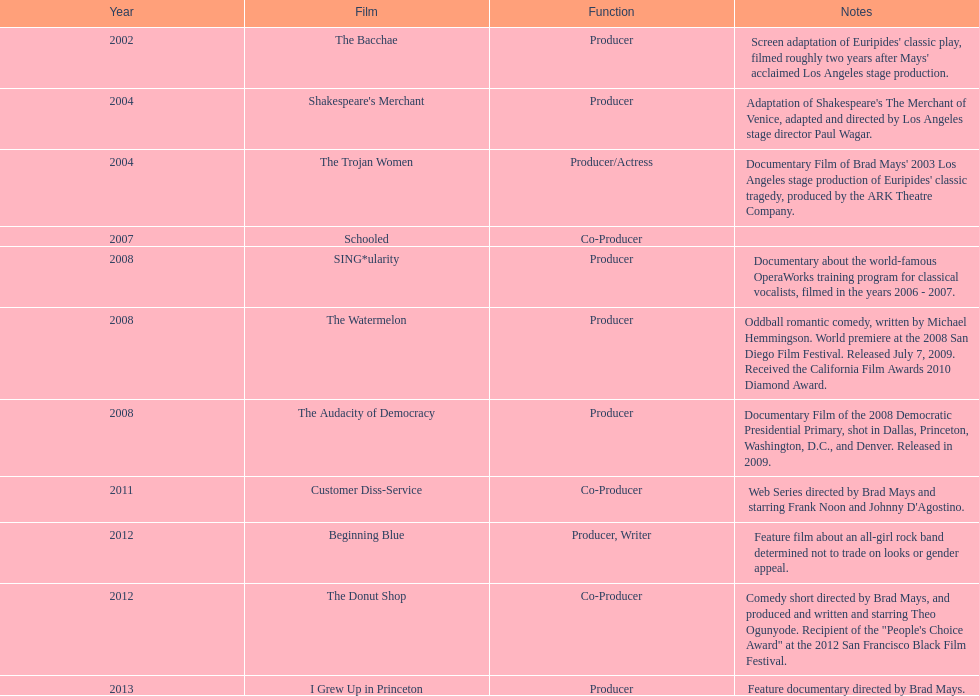Can you parse all the data within this table? {'header': ['Year', 'Film', 'Function', 'Notes'], 'rows': [['2002', 'The Bacchae', 'Producer', "Screen adaptation of Euripides' classic play, filmed roughly two years after Mays' acclaimed Los Angeles stage production."], ['2004', "Shakespeare's Merchant", 'Producer', "Adaptation of Shakespeare's The Merchant of Venice, adapted and directed by Los Angeles stage director Paul Wagar."], ['2004', 'The Trojan Women', 'Producer/Actress', "Documentary Film of Brad Mays' 2003 Los Angeles stage production of Euripides' classic tragedy, produced by the ARK Theatre Company."], ['2007', 'Schooled', 'Co-Producer', ''], ['2008', 'SING*ularity', 'Producer', 'Documentary about the world-famous OperaWorks training program for classical vocalists, filmed in the years 2006 - 2007.'], ['2008', 'The Watermelon', 'Producer', 'Oddball romantic comedy, written by Michael Hemmingson. World premiere at the 2008 San Diego Film Festival. Released July 7, 2009. Received the California Film Awards 2010 Diamond Award.'], ['2008', 'The Audacity of Democracy', 'Producer', 'Documentary Film of the 2008 Democratic Presidential Primary, shot in Dallas, Princeton, Washington, D.C., and Denver. Released in 2009.'], ['2011', 'Customer Diss-Service', 'Co-Producer', "Web Series directed by Brad Mays and starring Frank Noon and Johnny D'Agostino."], ['2012', 'Beginning Blue', 'Producer, Writer', 'Feature film about an all-girl rock band determined not to trade on looks or gender appeal.'], ['2012', 'The Donut Shop', 'Co-Producer', 'Comedy short directed by Brad Mays, and produced and written and starring Theo Ogunyode. Recipient of the "People\'s Choice Award" at the 2012 San Francisco Black Film Festival.'], ['2013', 'I Grew Up in Princeton', 'Producer', 'Feature documentary directed by Brad Mays.']]} By how many years did the film bacchae precede the release of the watermelon? 6. 